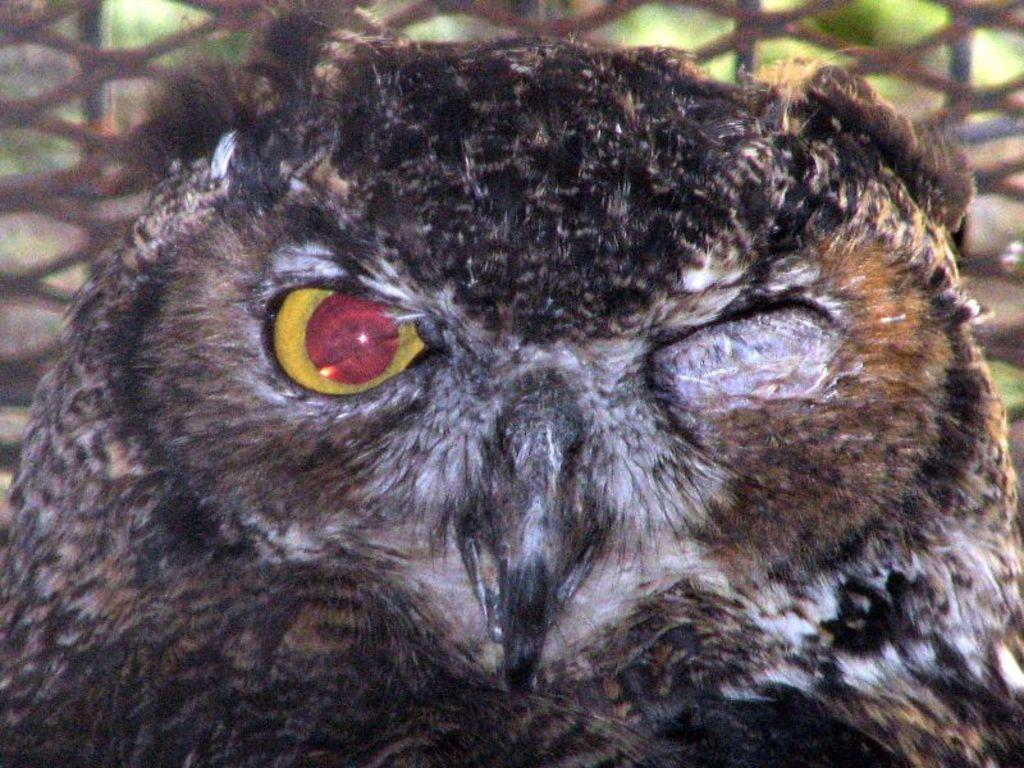What type of animal is in the picture? There is an owl in the picture. Can you describe the background of the picture? There is an object in the background of the picture, and greenery is also present. Where are the dolls placed in the image? There are no dolls present in the image. 